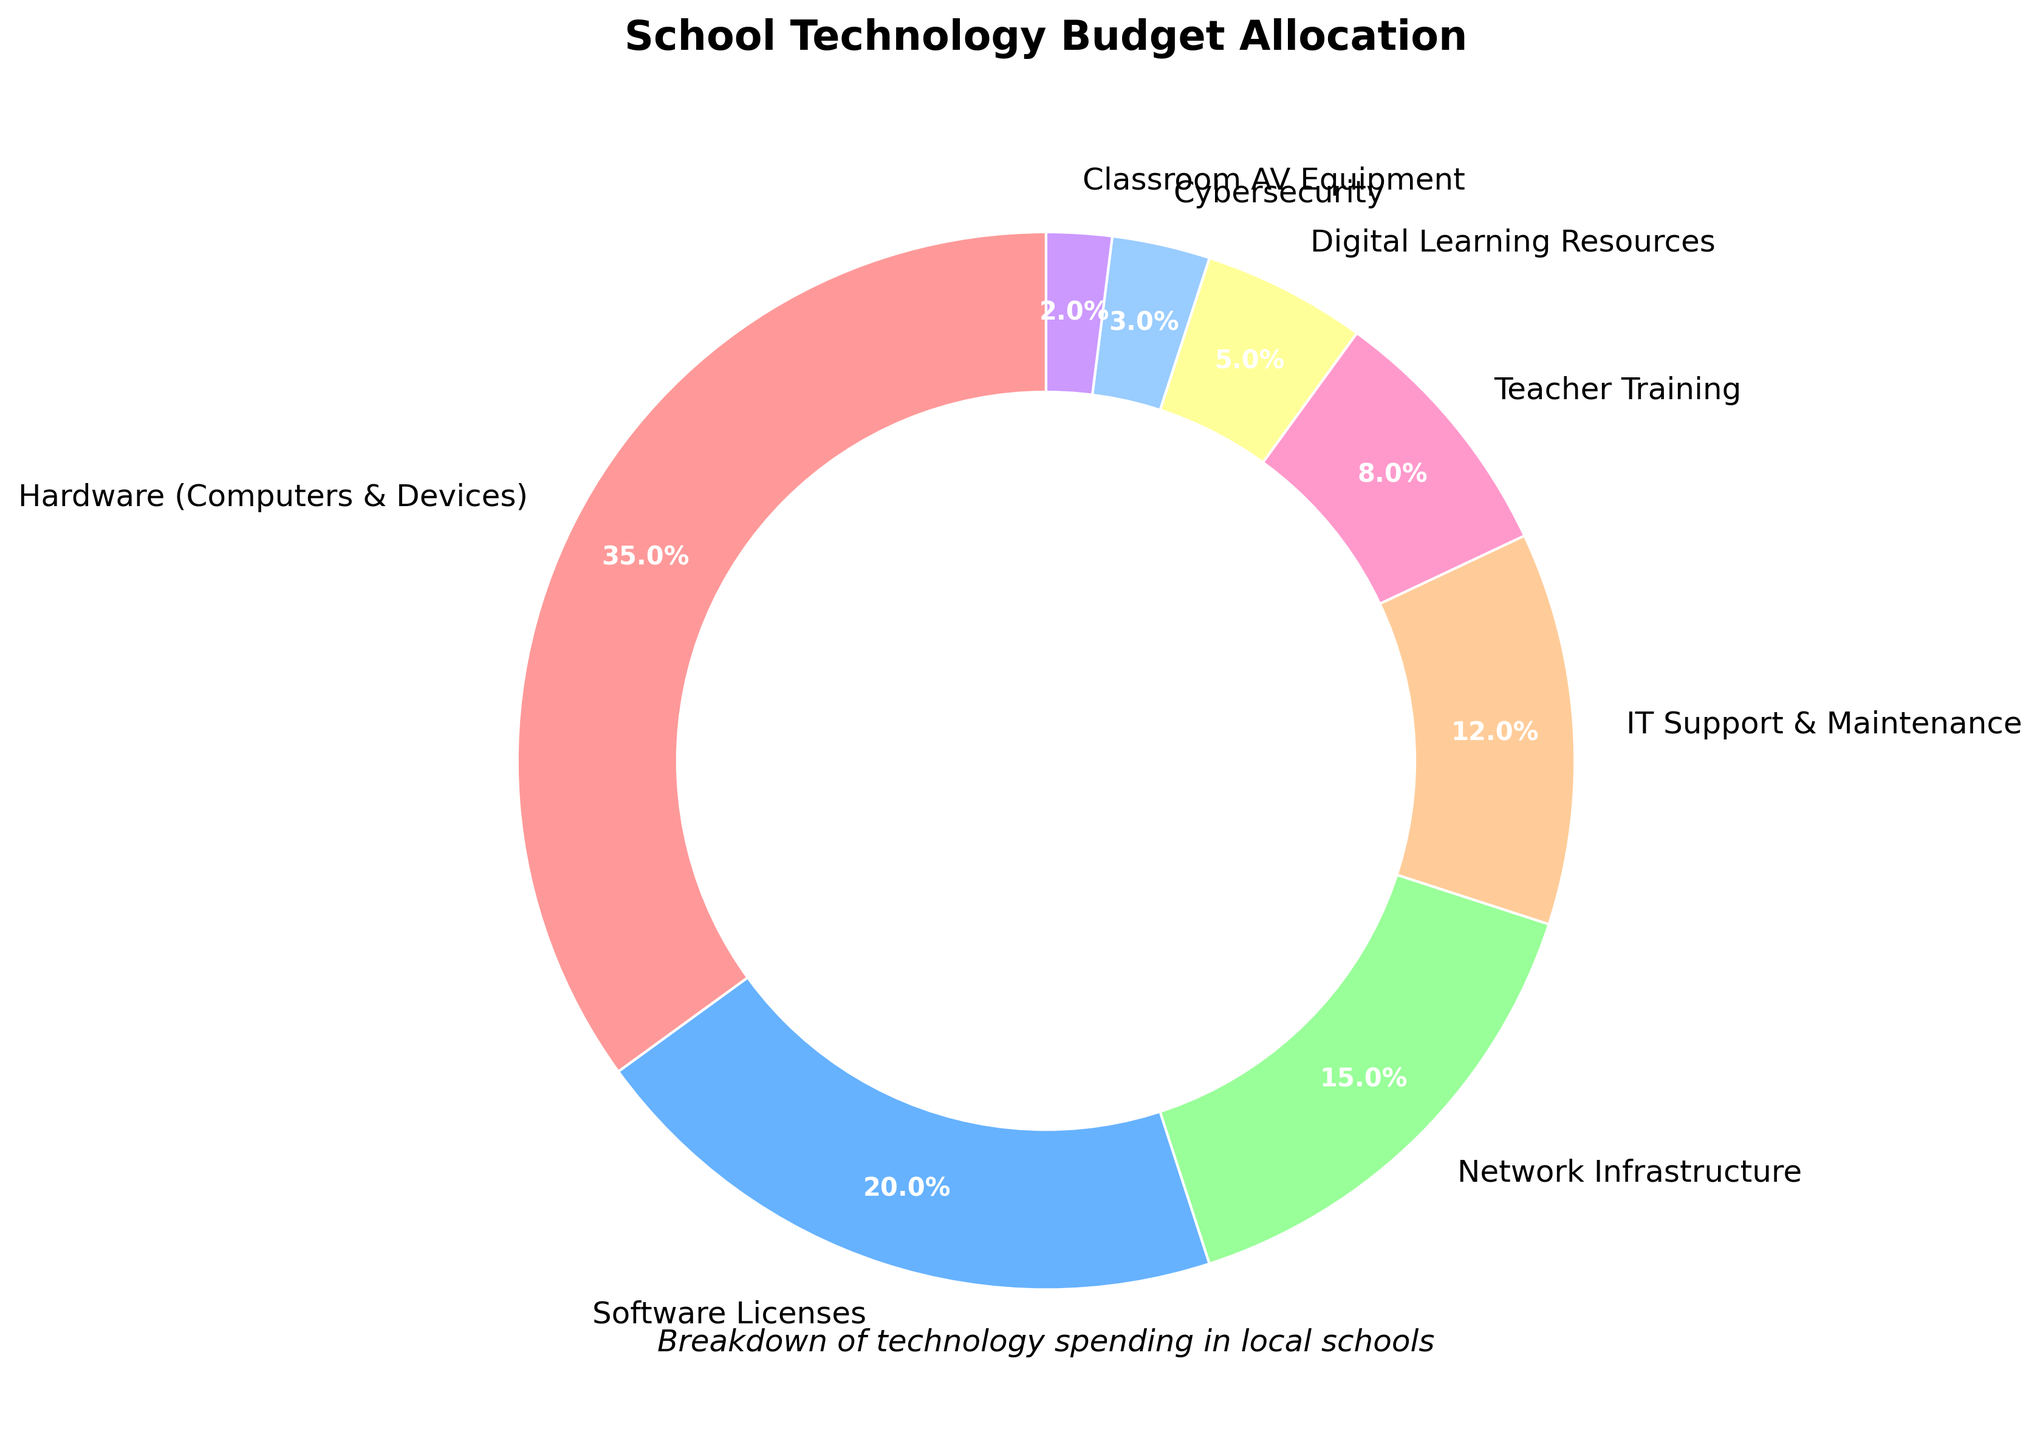Which category has the highest percentage of the budget? From the pie chart, the segment labeled "Hardware (Computers & Devices)" shows the highest percentage with 35%.
Answer: Hardware (Computers & Devices) What is the combined percentage for Teacher Training, Digital Learning Resources, and Cybersecurity? Add the percentages of Teacher Training (8%), Digital Learning Resources (5%), and Cybersecurity (3%). The total is 8% + 5% + 3% = 16%.
Answer: 16% How much more budget percentage is allocated to Software Licenses compared to Classroom AV Equipment? Subtract the percentage for Classroom AV Equipment (2%) from that of Software Licenses (20%). The difference is 20% - 2% = 18%.
Answer: 18% Which category is allocated a higher budget: Network Infrastructure or IT Support & Maintenance? Compare the percentages of Network Infrastructure (15%) and IT Support & Maintenance (12%). Network Infrastructure has a higher percentage.
Answer: Network Infrastructure What percentage of the budget is allocated to both Hardware (Computers & Devices) and Network Infrastructure combined? Add the percentages for Hardware (Computers & Devices) (35%) and Network Infrastructure (15%). The total is 35% + 15% = 50%.
Answer: 50% Does Teacher Training or Digital Learning Resources have a smaller budget allocation? Compare the percentages of Teacher Training (8%) and Digital Learning Resources (5%). Digital Learning Resources has a smaller percentage.
Answer: Digital Learning Resources Which colors represent the categories with the largest and smallest allocations? The largest allocation, Hardware (Computers & Devices) at 35%, is represented by red. The smallest allocation, Classroom AV Equipment at 2%, is represented by purple.
Answer: Red and purple What is the average percentage allocation of the three categories: Software Licenses, Network Infrastructure, and IT Support & Maintenance? Add the percentages for Software Licenses (20%), Network Infrastructure (15%), and IT Support & Maintenance (12%), then divide by 3. The average is (20% + 15% + 12%) / 3 = 47% / 3 ≈ 15.67%.
Answer: 15.67% If the budget for Software Licenses was doubled, what would the new total percentage allocation be? Double the percentage for Software Licenses (20%) to get 40%. Sum this with the current total percentage of 100%, considering the pie chart represents the full budget. The new total: 100% - 20% + 40% = 120%.
Answer: 120% 